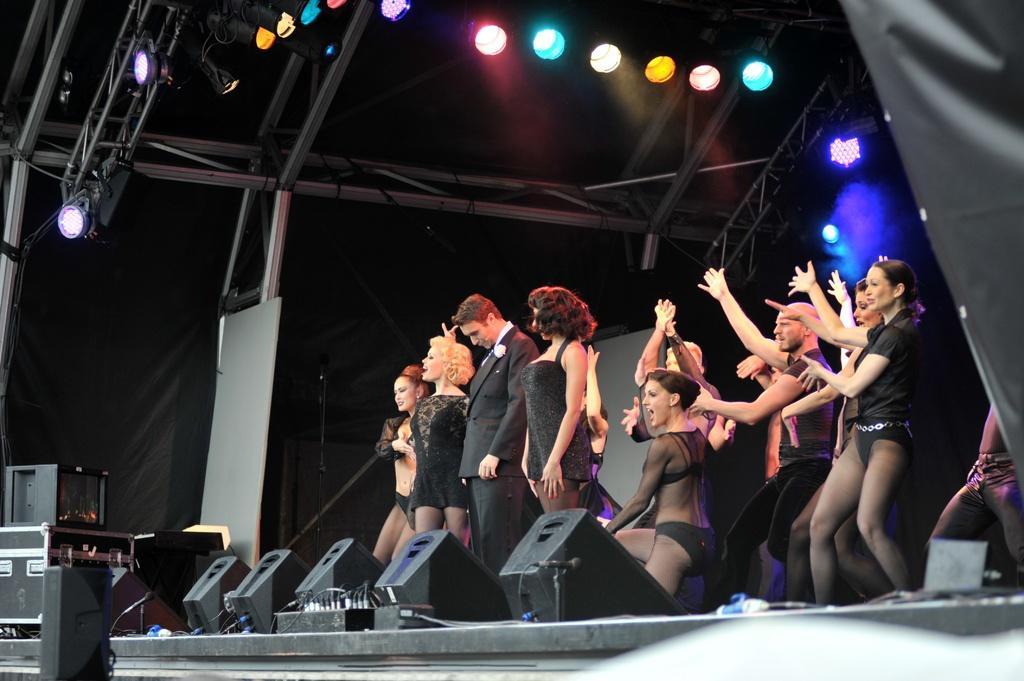Could you give a brief overview of what you see in this image? In this image there are group of persons dancing, there is a woman standing, there is a man standing, there are objects on the stage, there is a stand, there is a microphone, there are wires, there are objects towards the left of the image, there is a cloth towards the left of the image, there is an object towards the left of the image, there are lights. 